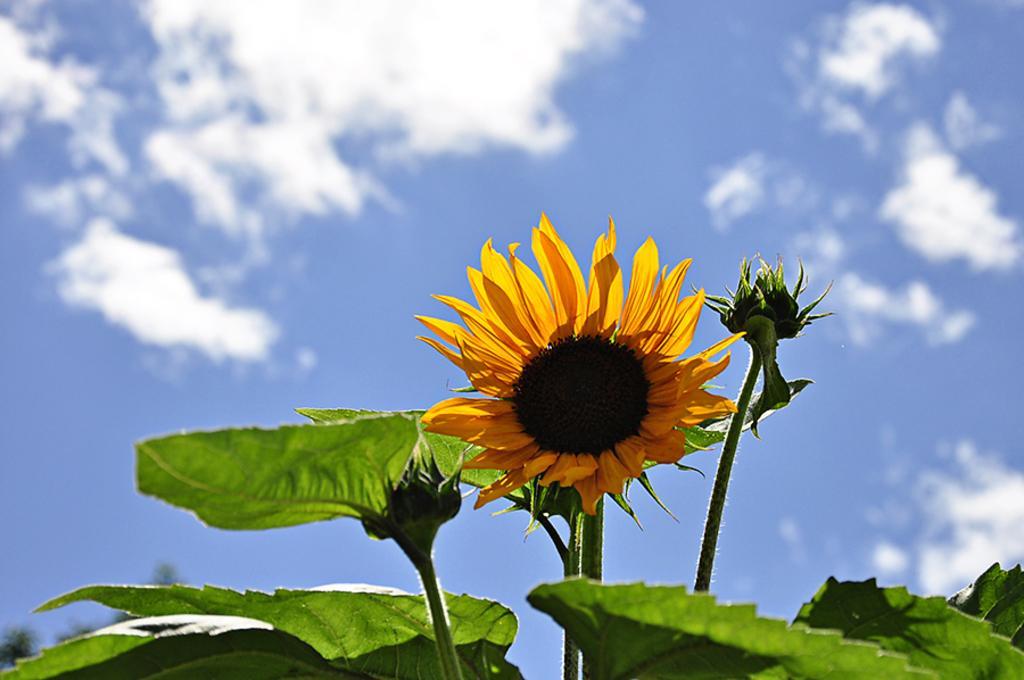How would you summarize this image in a sentence or two? In this image there are sunflower plants, in the background there is the sky. 